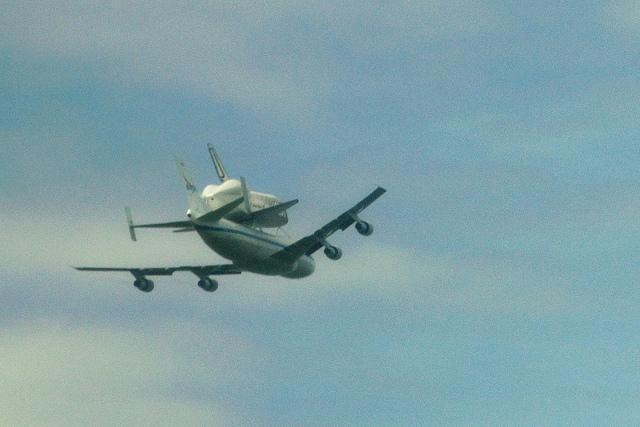How many turbine engines are visible in this picture?
Give a very brief answer. 4. How many planes pictured?
Give a very brief answer. 2. How many wheels are there?
Give a very brief answer. 0. How many engines on the plane?
Give a very brief answer. 4. How many planes in the sky?
Give a very brief answer. 2. 